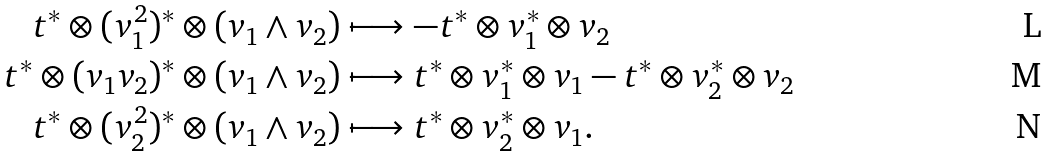<formula> <loc_0><loc_0><loc_500><loc_500>t ^ { * } \otimes ( v _ { 1 } ^ { 2 } ) ^ { * } \otimes ( v _ { 1 } \wedge v _ { 2 } ) & \longmapsto - t ^ { * } \otimes v _ { 1 } ^ { * } \otimes v _ { 2 } \\ t ^ { * } \otimes ( v _ { 1 } v _ { 2 } ) ^ { * } \otimes ( v _ { 1 } \wedge v _ { 2 } ) & \longmapsto t ^ { * } \otimes v _ { 1 } ^ { * } \otimes v _ { 1 } - t ^ { * } \otimes v _ { 2 } ^ { * } \otimes v _ { 2 } \\ t ^ { * } \otimes ( v _ { 2 } ^ { 2 } ) ^ { * } \otimes ( v _ { 1 } \wedge v _ { 2 } ) & \longmapsto t ^ { * } \otimes v _ { 2 } ^ { * } \otimes v _ { 1 } .</formula> 